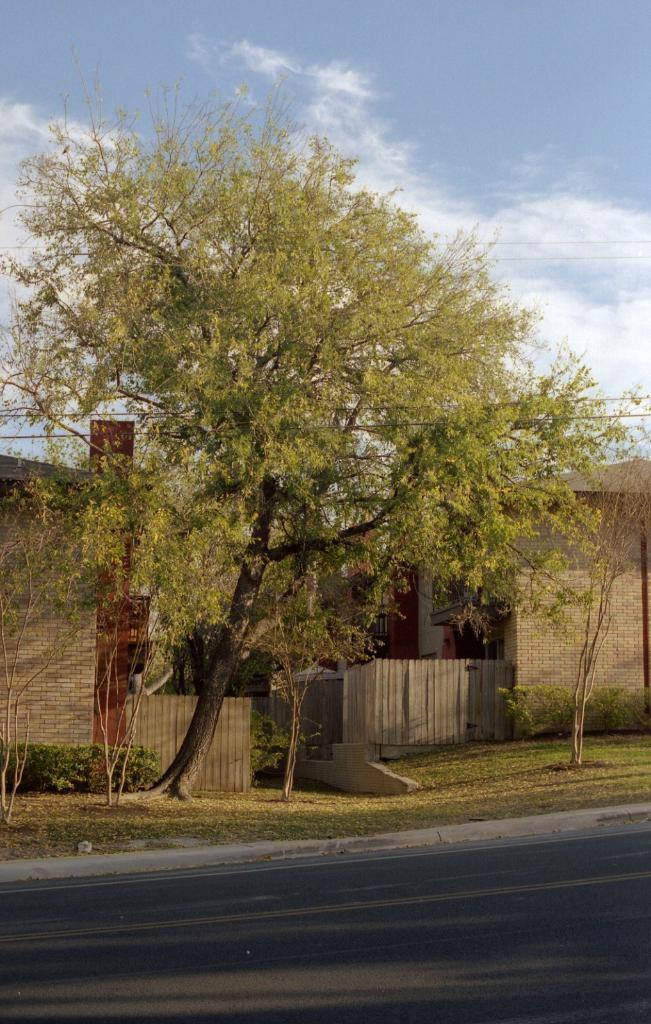What type of structures are visible in the image? There are houses in the image. What other natural elements can be seen in the image? There are trees in the image. What is located at the bottom of the image? There is a road at the bottom of the image. What is visible at the top of the image? The sky is visible at the top of the image. What can be observed in the sky? Clouds are present in the sky. How many channels can be seen running alongside the road in the image? There are no channels visible in the image; it only features houses, trees, a road, and the sky. 